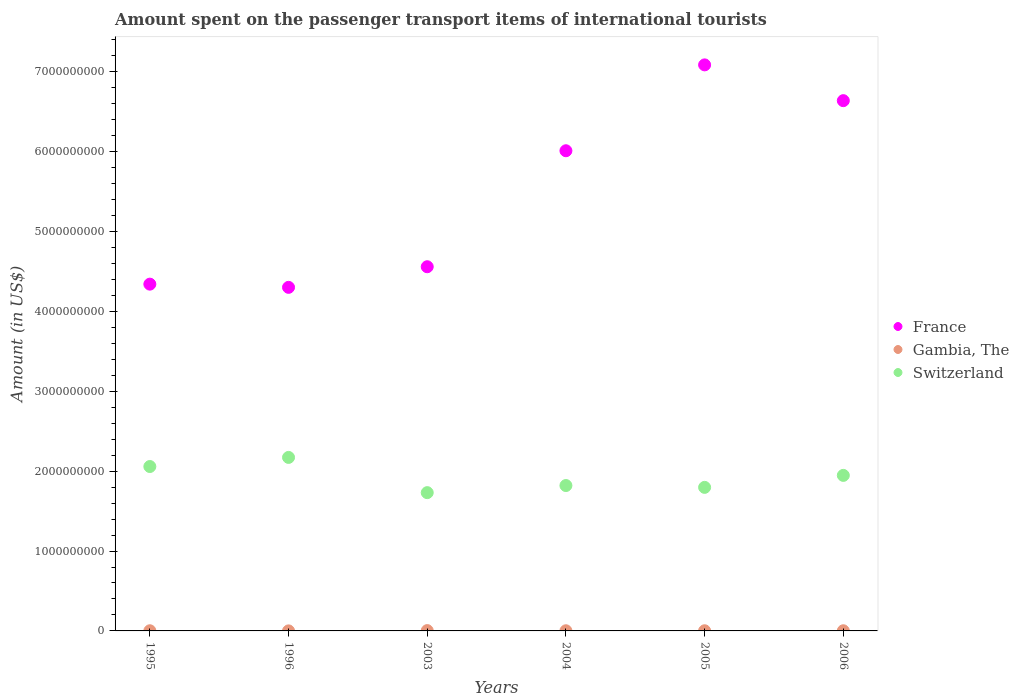How many different coloured dotlines are there?
Provide a succinct answer. 3. Is the number of dotlines equal to the number of legend labels?
Your response must be concise. Yes. What is the amount spent on the passenger transport items of international tourists in Switzerland in 2004?
Offer a very short reply. 1.82e+09. Across all years, what is the maximum amount spent on the passenger transport items of international tourists in Switzerland?
Ensure brevity in your answer.  2.17e+09. Across all years, what is the minimum amount spent on the passenger transport items of international tourists in Switzerland?
Ensure brevity in your answer.  1.73e+09. What is the total amount spent on the passenger transport items of international tourists in Switzerland in the graph?
Your answer should be very brief. 1.15e+1. What is the difference between the amount spent on the passenger transport items of international tourists in Switzerland in 1996 and that in 2004?
Keep it short and to the point. 3.52e+08. What is the difference between the amount spent on the passenger transport items of international tourists in Switzerland in 2005 and the amount spent on the passenger transport items of international tourists in France in 1996?
Offer a very short reply. -2.50e+09. What is the average amount spent on the passenger transport items of international tourists in Gambia, The per year?
Make the answer very short. 2.08e+06. In the year 1996, what is the difference between the amount spent on the passenger transport items of international tourists in Switzerland and amount spent on the passenger transport items of international tourists in Gambia, The?
Offer a terse response. 2.17e+09. Is the amount spent on the passenger transport items of international tourists in Switzerland in 2004 less than that in 2006?
Your response must be concise. Yes. Is the difference between the amount spent on the passenger transport items of international tourists in Switzerland in 2003 and 2006 greater than the difference between the amount spent on the passenger transport items of international tourists in Gambia, The in 2003 and 2006?
Make the answer very short. No. What is the difference between the highest and the second highest amount spent on the passenger transport items of international tourists in Switzerland?
Provide a short and direct response. 1.14e+08. What is the difference between the highest and the lowest amount spent on the passenger transport items of international tourists in France?
Keep it short and to the point. 2.78e+09. In how many years, is the amount spent on the passenger transport items of international tourists in Gambia, The greater than the average amount spent on the passenger transport items of international tourists in Gambia, The taken over all years?
Make the answer very short. 1. Is it the case that in every year, the sum of the amount spent on the passenger transport items of international tourists in France and amount spent on the passenger transport items of international tourists in Gambia, The  is greater than the amount spent on the passenger transport items of international tourists in Switzerland?
Your answer should be compact. Yes. Does the amount spent on the passenger transport items of international tourists in Gambia, The monotonically increase over the years?
Give a very brief answer. No. Is the amount spent on the passenger transport items of international tourists in Gambia, The strictly less than the amount spent on the passenger transport items of international tourists in Switzerland over the years?
Provide a short and direct response. Yes. Does the graph contain any zero values?
Provide a succinct answer. No. Where does the legend appear in the graph?
Ensure brevity in your answer.  Center right. What is the title of the graph?
Provide a succinct answer. Amount spent on the passenger transport items of international tourists. Does "Latin America(all income levels)" appear as one of the legend labels in the graph?
Your response must be concise. No. What is the Amount (in US$) of France in 1995?
Your answer should be compact. 4.34e+09. What is the Amount (in US$) of Gambia, The in 1995?
Offer a terse response. 2.00e+06. What is the Amount (in US$) of Switzerland in 1995?
Your response must be concise. 2.06e+09. What is the Amount (in US$) of France in 1996?
Give a very brief answer. 4.30e+09. What is the Amount (in US$) of Gambia, The in 1996?
Provide a short and direct response. 5.00e+05. What is the Amount (in US$) in Switzerland in 1996?
Your answer should be compact. 2.17e+09. What is the Amount (in US$) of France in 2003?
Ensure brevity in your answer.  4.56e+09. What is the Amount (in US$) in Switzerland in 2003?
Your answer should be very brief. 1.73e+09. What is the Amount (in US$) in France in 2004?
Ensure brevity in your answer.  6.01e+09. What is the Amount (in US$) in Switzerland in 2004?
Provide a succinct answer. 1.82e+09. What is the Amount (in US$) in France in 2005?
Make the answer very short. 7.09e+09. What is the Amount (in US$) of Switzerland in 2005?
Your answer should be compact. 1.80e+09. What is the Amount (in US$) of France in 2006?
Ensure brevity in your answer.  6.64e+09. What is the Amount (in US$) of Gambia, The in 2006?
Provide a short and direct response. 2.00e+06. What is the Amount (in US$) of Switzerland in 2006?
Provide a short and direct response. 1.95e+09. Across all years, what is the maximum Amount (in US$) in France?
Your response must be concise. 7.09e+09. Across all years, what is the maximum Amount (in US$) in Gambia, The?
Give a very brief answer. 4.00e+06. Across all years, what is the maximum Amount (in US$) in Switzerland?
Offer a terse response. 2.17e+09. Across all years, what is the minimum Amount (in US$) in France?
Offer a terse response. 4.30e+09. Across all years, what is the minimum Amount (in US$) in Switzerland?
Offer a terse response. 1.73e+09. What is the total Amount (in US$) of France in the graph?
Offer a terse response. 3.29e+1. What is the total Amount (in US$) of Gambia, The in the graph?
Give a very brief answer. 1.25e+07. What is the total Amount (in US$) in Switzerland in the graph?
Provide a short and direct response. 1.15e+1. What is the difference between the Amount (in US$) in France in 1995 and that in 1996?
Give a very brief answer. 4.00e+07. What is the difference between the Amount (in US$) in Gambia, The in 1995 and that in 1996?
Make the answer very short. 1.50e+06. What is the difference between the Amount (in US$) of Switzerland in 1995 and that in 1996?
Keep it short and to the point. -1.14e+08. What is the difference between the Amount (in US$) in France in 1995 and that in 2003?
Provide a succinct answer. -2.18e+08. What is the difference between the Amount (in US$) of Gambia, The in 1995 and that in 2003?
Your answer should be compact. -2.00e+06. What is the difference between the Amount (in US$) in Switzerland in 1995 and that in 2003?
Offer a terse response. 3.27e+08. What is the difference between the Amount (in US$) of France in 1995 and that in 2004?
Your answer should be compact. -1.67e+09. What is the difference between the Amount (in US$) in Switzerland in 1995 and that in 2004?
Your response must be concise. 2.38e+08. What is the difference between the Amount (in US$) of France in 1995 and that in 2005?
Make the answer very short. -2.74e+09. What is the difference between the Amount (in US$) of Switzerland in 1995 and that in 2005?
Your answer should be compact. 2.61e+08. What is the difference between the Amount (in US$) in France in 1995 and that in 2006?
Ensure brevity in your answer.  -2.30e+09. What is the difference between the Amount (in US$) of Switzerland in 1995 and that in 2006?
Provide a succinct answer. 1.11e+08. What is the difference between the Amount (in US$) of France in 1996 and that in 2003?
Make the answer very short. -2.58e+08. What is the difference between the Amount (in US$) in Gambia, The in 1996 and that in 2003?
Provide a succinct answer. -3.50e+06. What is the difference between the Amount (in US$) of Switzerland in 1996 and that in 2003?
Provide a succinct answer. 4.41e+08. What is the difference between the Amount (in US$) in France in 1996 and that in 2004?
Provide a short and direct response. -1.71e+09. What is the difference between the Amount (in US$) in Gambia, The in 1996 and that in 2004?
Your answer should be very brief. -1.50e+06. What is the difference between the Amount (in US$) in Switzerland in 1996 and that in 2004?
Your response must be concise. 3.52e+08. What is the difference between the Amount (in US$) of France in 1996 and that in 2005?
Give a very brief answer. -2.78e+09. What is the difference between the Amount (in US$) of Gambia, The in 1996 and that in 2005?
Your response must be concise. -1.50e+06. What is the difference between the Amount (in US$) in Switzerland in 1996 and that in 2005?
Offer a very short reply. 3.75e+08. What is the difference between the Amount (in US$) of France in 1996 and that in 2006?
Provide a succinct answer. -2.34e+09. What is the difference between the Amount (in US$) of Gambia, The in 1996 and that in 2006?
Provide a short and direct response. -1.50e+06. What is the difference between the Amount (in US$) in Switzerland in 1996 and that in 2006?
Provide a short and direct response. 2.25e+08. What is the difference between the Amount (in US$) in France in 2003 and that in 2004?
Your answer should be compact. -1.45e+09. What is the difference between the Amount (in US$) of Switzerland in 2003 and that in 2004?
Provide a short and direct response. -8.90e+07. What is the difference between the Amount (in US$) in France in 2003 and that in 2005?
Give a very brief answer. -2.53e+09. What is the difference between the Amount (in US$) in Switzerland in 2003 and that in 2005?
Ensure brevity in your answer.  -6.60e+07. What is the difference between the Amount (in US$) of France in 2003 and that in 2006?
Provide a succinct answer. -2.08e+09. What is the difference between the Amount (in US$) of Gambia, The in 2003 and that in 2006?
Give a very brief answer. 2.00e+06. What is the difference between the Amount (in US$) of Switzerland in 2003 and that in 2006?
Ensure brevity in your answer.  -2.16e+08. What is the difference between the Amount (in US$) of France in 2004 and that in 2005?
Your answer should be compact. -1.08e+09. What is the difference between the Amount (in US$) of Switzerland in 2004 and that in 2005?
Make the answer very short. 2.30e+07. What is the difference between the Amount (in US$) of France in 2004 and that in 2006?
Offer a very short reply. -6.27e+08. What is the difference between the Amount (in US$) in Switzerland in 2004 and that in 2006?
Offer a terse response. -1.27e+08. What is the difference between the Amount (in US$) in France in 2005 and that in 2006?
Offer a very short reply. 4.48e+08. What is the difference between the Amount (in US$) in Gambia, The in 2005 and that in 2006?
Give a very brief answer. 0. What is the difference between the Amount (in US$) in Switzerland in 2005 and that in 2006?
Your answer should be compact. -1.50e+08. What is the difference between the Amount (in US$) of France in 1995 and the Amount (in US$) of Gambia, The in 1996?
Give a very brief answer. 4.34e+09. What is the difference between the Amount (in US$) of France in 1995 and the Amount (in US$) of Switzerland in 1996?
Offer a very short reply. 2.17e+09. What is the difference between the Amount (in US$) in Gambia, The in 1995 and the Amount (in US$) in Switzerland in 1996?
Keep it short and to the point. -2.17e+09. What is the difference between the Amount (in US$) of France in 1995 and the Amount (in US$) of Gambia, The in 2003?
Provide a short and direct response. 4.34e+09. What is the difference between the Amount (in US$) of France in 1995 and the Amount (in US$) of Switzerland in 2003?
Offer a very short reply. 2.61e+09. What is the difference between the Amount (in US$) in Gambia, The in 1995 and the Amount (in US$) in Switzerland in 2003?
Keep it short and to the point. -1.73e+09. What is the difference between the Amount (in US$) of France in 1995 and the Amount (in US$) of Gambia, The in 2004?
Give a very brief answer. 4.34e+09. What is the difference between the Amount (in US$) in France in 1995 and the Amount (in US$) in Switzerland in 2004?
Provide a succinct answer. 2.52e+09. What is the difference between the Amount (in US$) of Gambia, The in 1995 and the Amount (in US$) of Switzerland in 2004?
Provide a short and direct response. -1.82e+09. What is the difference between the Amount (in US$) of France in 1995 and the Amount (in US$) of Gambia, The in 2005?
Ensure brevity in your answer.  4.34e+09. What is the difference between the Amount (in US$) in France in 1995 and the Amount (in US$) in Switzerland in 2005?
Make the answer very short. 2.54e+09. What is the difference between the Amount (in US$) of Gambia, The in 1995 and the Amount (in US$) of Switzerland in 2005?
Offer a terse response. -1.80e+09. What is the difference between the Amount (in US$) in France in 1995 and the Amount (in US$) in Gambia, The in 2006?
Give a very brief answer. 4.34e+09. What is the difference between the Amount (in US$) in France in 1995 and the Amount (in US$) in Switzerland in 2006?
Your response must be concise. 2.39e+09. What is the difference between the Amount (in US$) of Gambia, The in 1995 and the Amount (in US$) of Switzerland in 2006?
Your answer should be compact. -1.94e+09. What is the difference between the Amount (in US$) of France in 1996 and the Amount (in US$) of Gambia, The in 2003?
Your answer should be very brief. 4.30e+09. What is the difference between the Amount (in US$) of France in 1996 and the Amount (in US$) of Switzerland in 2003?
Give a very brief answer. 2.57e+09. What is the difference between the Amount (in US$) in Gambia, The in 1996 and the Amount (in US$) in Switzerland in 2003?
Give a very brief answer. -1.73e+09. What is the difference between the Amount (in US$) of France in 1996 and the Amount (in US$) of Gambia, The in 2004?
Provide a succinct answer. 4.30e+09. What is the difference between the Amount (in US$) of France in 1996 and the Amount (in US$) of Switzerland in 2004?
Your answer should be very brief. 2.48e+09. What is the difference between the Amount (in US$) of Gambia, The in 1996 and the Amount (in US$) of Switzerland in 2004?
Keep it short and to the point. -1.82e+09. What is the difference between the Amount (in US$) of France in 1996 and the Amount (in US$) of Gambia, The in 2005?
Keep it short and to the point. 4.30e+09. What is the difference between the Amount (in US$) of France in 1996 and the Amount (in US$) of Switzerland in 2005?
Your answer should be compact. 2.50e+09. What is the difference between the Amount (in US$) of Gambia, The in 1996 and the Amount (in US$) of Switzerland in 2005?
Give a very brief answer. -1.80e+09. What is the difference between the Amount (in US$) in France in 1996 and the Amount (in US$) in Gambia, The in 2006?
Your answer should be compact. 4.30e+09. What is the difference between the Amount (in US$) in France in 1996 and the Amount (in US$) in Switzerland in 2006?
Provide a succinct answer. 2.35e+09. What is the difference between the Amount (in US$) in Gambia, The in 1996 and the Amount (in US$) in Switzerland in 2006?
Your response must be concise. -1.95e+09. What is the difference between the Amount (in US$) of France in 2003 and the Amount (in US$) of Gambia, The in 2004?
Your answer should be compact. 4.56e+09. What is the difference between the Amount (in US$) of France in 2003 and the Amount (in US$) of Switzerland in 2004?
Offer a very short reply. 2.74e+09. What is the difference between the Amount (in US$) of Gambia, The in 2003 and the Amount (in US$) of Switzerland in 2004?
Offer a very short reply. -1.82e+09. What is the difference between the Amount (in US$) of France in 2003 and the Amount (in US$) of Gambia, The in 2005?
Provide a succinct answer. 4.56e+09. What is the difference between the Amount (in US$) of France in 2003 and the Amount (in US$) of Switzerland in 2005?
Your answer should be very brief. 2.76e+09. What is the difference between the Amount (in US$) in Gambia, The in 2003 and the Amount (in US$) in Switzerland in 2005?
Provide a succinct answer. -1.79e+09. What is the difference between the Amount (in US$) of France in 2003 and the Amount (in US$) of Gambia, The in 2006?
Give a very brief answer. 4.56e+09. What is the difference between the Amount (in US$) in France in 2003 and the Amount (in US$) in Switzerland in 2006?
Make the answer very short. 2.61e+09. What is the difference between the Amount (in US$) of Gambia, The in 2003 and the Amount (in US$) of Switzerland in 2006?
Provide a short and direct response. -1.94e+09. What is the difference between the Amount (in US$) in France in 2004 and the Amount (in US$) in Gambia, The in 2005?
Provide a succinct answer. 6.01e+09. What is the difference between the Amount (in US$) of France in 2004 and the Amount (in US$) of Switzerland in 2005?
Your response must be concise. 4.21e+09. What is the difference between the Amount (in US$) of Gambia, The in 2004 and the Amount (in US$) of Switzerland in 2005?
Ensure brevity in your answer.  -1.80e+09. What is the difference between the Amount (in US$) of France in 2004 and the Amount (in US$) of Gambia, The in 2006?
Your response must be concise. 6.01e+09. What is the difference between the Amount (in US$) in France in 2004 and the Amount (in US$) in Switzerland in 2006?
Provide a succinct answer. 4.06e+09. What is the difference between the Amount (in US$) in Gambia, The in 2004 and the Amount (in US$) in Switzerland in 2006?
Keep it short and to the point. -1.94e+09. What is the difference between the Amount (in US$) of France in 2005 and the Amount (in US$) of Gambia, The in 2006?
Your answer should be very brief. 7.08e+09. What is the difference between the Amount (in US$) of France in 2005 and the Amount (in US$) of Switzerland in 2006?
Your answer should be very brief. 5.14e+09. What is the difference between the Amount (in US$) in Gambia, The in 2005 and the Amount (in US$) in Switzerland in 2006?
Ensure brevity in your answer.  -1.94e+09. What is the average Amount (in US$) of France per year?
Ensure brevity in your answer.  5.49e+09. What is the average Amount (in US$) in Gambia, The per year?
Offer a very short reply. 2.08e+06. What is the average Amount (in US$) of Switzerland per year?
Provide a succinct answer. 1.92e+09. In the year 1995, what is the difference between the Amount (in US$) in France and Amount (in US$) in Gambia, The?
Provide a short and direct response. 4.34e+09. In the year 1995, what is the difference between the Amount (in US$) in France and Amount (in US$) in Switzerland?
Offer a very short reply. 2.28e+09. In the year 1995, what is the difference between the Amount (in US$) of Gambia, The and Amount (in US$) of Switzerland?
Make the answer very short. -2.06e+09. In the year 1996, what is the difference between the Amount (in US$) of France and Amount (in US$) of Gambia, The?
Make the answer very short. 4.30e+09. In the year 1996, what is the difference between the Amount (in US$) in France and Amount (in US$) in Switzerland?
Offer a terse response. 2.13e+09. In the year 1996, what is the difference between the Amount (in US$) in Gambia, The and Amount (in US$) in Switzerland?
Make the answer very short. -2.17e+09. In the year 2003, what is the difference between the Amount (in US$) of France and Amount (in US$) of Gambia, The?
Your answer should be very brief. 4.56e+09. In the year 2003, what is the difference between the Amount (in US$) in France and Amount (in US$) in Switzerland?
Give a very brief answer. 2.83e+09. In the year 2003, what is the difference between the Amount (in US$) in Gambia, The and Amount (in US$) in Switzerland?
Your answer should be compact. -1.73e+09. In the year 2004, what is the difference between the Amount (in US$) of France and Amount (in US$) of Gambia, The?
Make the answer very short. 6.01e+09. In the year 2004, what is the difference between the Amount (in US$) of France and Amount (in US$) of Switzerland?
Give a very brief answer. 4.19e+09. In the year 2004, what is the difference between the Amount (in US$) of Gambia, The and Amount (in US$) of Switzerland?
Offer a terse response. -1.82e+09. In the year 2005, what is the difference between the Amount (in US$) of France and Amount (in US$) of Gambia, The?
Your answer should be very brief. 7.08e+09. In the year 2005, what is the difference between the Amount (in US$) in France and Amount (in US$) in Switzerland?
Your answer should be compact. 5.29e+09. In the year 2005, what is the difference between the Amount (in US$) of Gambia, The and Amount (in US$) of Switzerland?
Provide a short and direct response. -1.80e+09. In the year 2006, what is the difference between the Amount (in US$) in France and Amount (in US$) in Gambia, The?
Offer a terse response. 6.64e+09. In the year 2006, what is the difference between the Amount (in US$) of France and Amount (in US$) of Switzerland?
Your response must be concise. 4.69e+09. In the year 2006, what is the difference between the Amount (in US$) in Gambia, The and Amount (in US$) in Switzerland?
Offer a terse response. -1.94e+09. What is the ratio of the Amount (in US$) in France in 1995 to that in 1996?
Keep it short and to the point. 1.01. What is the ratio of the Amount (in US$) in Switzerland in 1995 to that in 1996?
Give a very brief answer. 0.95. What is the ratio of the Amount (in US$) in France in 1995 to that in 2003?
Keep it short and to the point. 0.95. What is the ratio of the Amount (in US$) of Switzerland in 1995 to that in 2003?
Ensure brevity in your answer.  1.19. What is the ratio of the Amount (in US$) in France in 1995 to that in 2004?
Make the answer very short. 0.72. What is the ratio of the Amount (in US$) in Gambia, The in 1995 to that in 2004?
Give a very brief answer. 1. What is the ratio of the Amount (in US$) in Switzerland in 1995 to that in 2004?
Provide a short and direct response. 1.13. What is the ratio of the Amount (in US$) in France in 1995 to that in 2005?
Your response must be concise. 0.61. What is the ratio of the Amount (in US$) of Gambia, The in 1995 to that in 2005?
Your response must be concise. 1. What is the ratio of the Amount (in US$) in Switzerland in 1995 to that in 2005?
Offer a terse response. 1.15. What is the ratio of the Amount (in US$) in France in 1995 to that in 2006?
Provide a short and direct response. 0.65. What is the ratio of the Amount (in US$) of Gambia, The in 1995 to that in 2006?
Your response must be concise. 1. What is the ratio of the Amount (in US$) of Switzerland in 1995 to that in 2006?
Offer a very short reply. 1.06. What is the ratio of the Amount (in US$) in France in 1996 to that in 2003?
Your response must be concise. 0.94. What is the ratio of the Amount (in US$) in Switzerland in 1996 to that in 2003?
Make the answer very short. 1.25. What is the ratio of the Amount (in US$) in France in 1996 to that in 2004?
Your response must be concise. 0.72. What is the ratio of the Amount (in US$) of Gambia, The in 1996 to that in 2004?
Your answer should be very brief. 0.25. What is the ratio of the Amount (in US$) of Switzerland in 1996 to that in 2004?
Offer a terse response. 1.19. What is the ratio of the Amount (in US$) in France in 1996 to that in 2005?
Your answer should be compact. 0.61. What is the ratio of the Amount (in US$) in Switzerland in 1996 to that in 2005?
Your answer should be compact. 1.21. What is the ratio of the Amount (in US$) of France in 1996 to that in 2006?
Make the answer very short. 0.65. What is the ratio of the Amount (in US$) of Switzerland in 1996 to that in 2006?
Make the answer very short. 1.12. What is the ratio of the Amount (in US$) of France in 2003 to that in 2004?
Offer a terse response. 0.76. What is the ratio of the Amount (in US$) in Switzerland in 2003 to that in 2004?
Your answer should be very brief. 0.95. What is the ratio of the Amount (in US$) of France in 2003 to that in 2005?
Provide a short and direct response. 0.64. What is the ratio of the Amount (in US$) of Gambia, The in 2003 to that in 2005?
Keep it short and to the point. 2. What is the ratio of the Amount (in US$) in Switzerland in 2003 to that in 2005?
Provide a succinct answer. 0.96. What is the ratio of the Amount (in US$) of France in 2003 to that in 2006?
Your answer should be compact. 0.69. What is the ratio of the Amount (in US$) of Switzerland in 2003 to that in 2006?
Your answer should be compact. 0.89. What is the ratio of the Amount (in US$) in France in 2004 to that in 2005?
Provide a succinct answer. 0.85. What is the ratio of the Amount (in US$) of Gambia, The in 2004 to that in 2005?
Provide a succinct answer. 1. What is the ratio of the Amount (in US$) in Switzerland in 2004 to that in 2005?
Keep it short and to the point. 1.01. What is the ratio of the Amount (in US$) in France in 2004 to that in 2006?
Offer a terse response. 0.91. What is the ratio of the Amount (in US$) of Switzerland in 2004 to that in 2006?
Your response must be concise. 0.93. What is the ratio of the Amount (in US$) in France in 2005 to that in 2006?
Provide a short and direct response. 1.07. What is the ratio of the Amount (in US$) in Switzerland in 2005 to that in 2006?
Offer a terse response. 0.92. What is the difference between the highest and the second highest Amount (in US$) of France?
Provide a short and direct response. 4.48e+08. What is the difference between the highest and the second highest Amount (in US$) of Gambia, The?
Ensure brevity in your answer.  2.00e+06. What is the difference between the highest and the second highest Amount (in US$) in Switzerland?
Keep it short and to the point. 1.14e+08. What is the difference between the highest and the lowest Amount (in US$) in France?
Provide a succinct answer. 2.78e+09. What is the difference between the highest and the lowest Amount (in US$) of Gambia, The?
Your response must be concise. 3.50e+06. What is the difference between the highest and the lowest Amount (in US$) of Switzerland?
Offer a very short reply. 4.41e+08. 